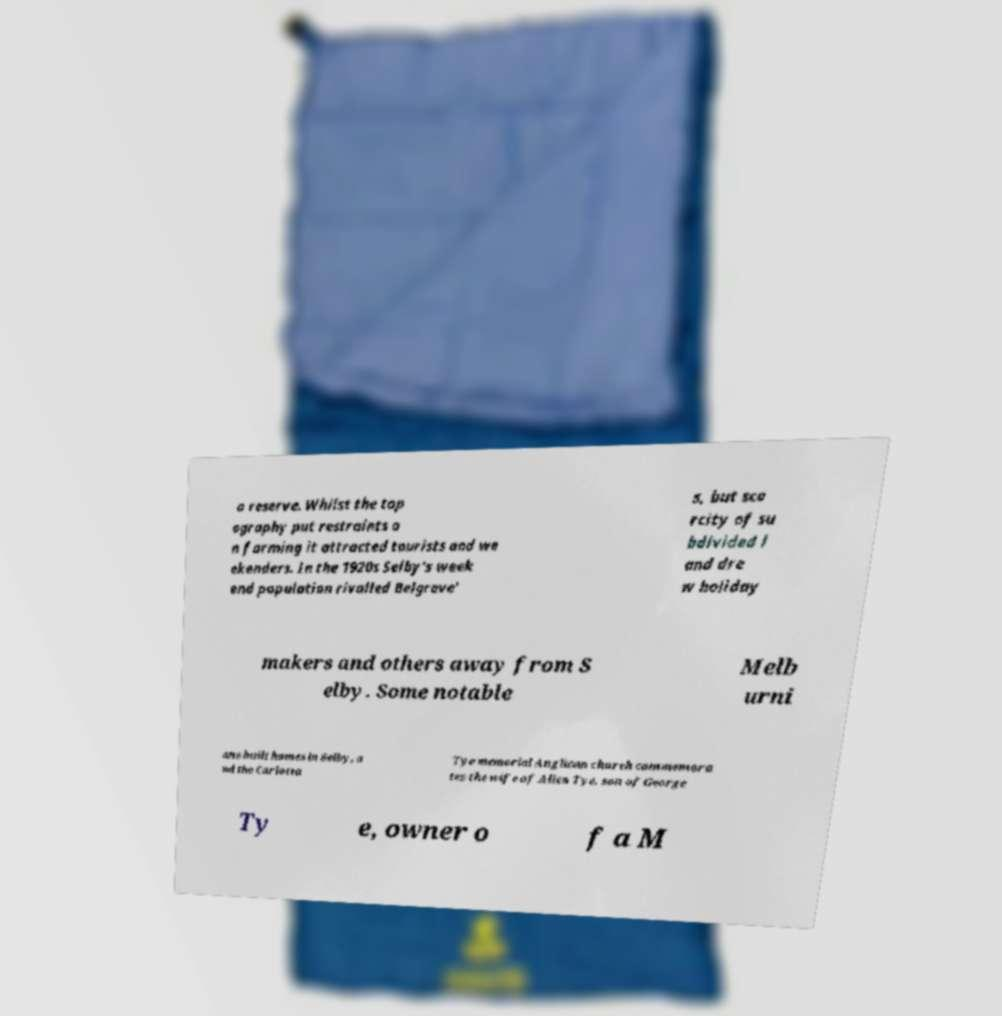Could you assist in decoding the text presented in this image and type it out clearly? a reserve. Whilst the top ography put restraints o n farming it attracted tourists and we ekenders. In the 1920s Selby's week end population rivalled Belgrave' s, but sca rcity of su bdivided l and dre w holiday makers and others away from S elby. Some notable Melb urni ans built homes in Selby, a nd the Carlotta Tye memorial Anglican church commemora tes the wife of Allen Tye, son of George Ty e, owner o f a M 